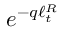Convert formula to latex. <formula><loc_0><loc_0><loc_500><loc_500>e ^ { - q \ell _ { t } ^ { R } }</formula> 